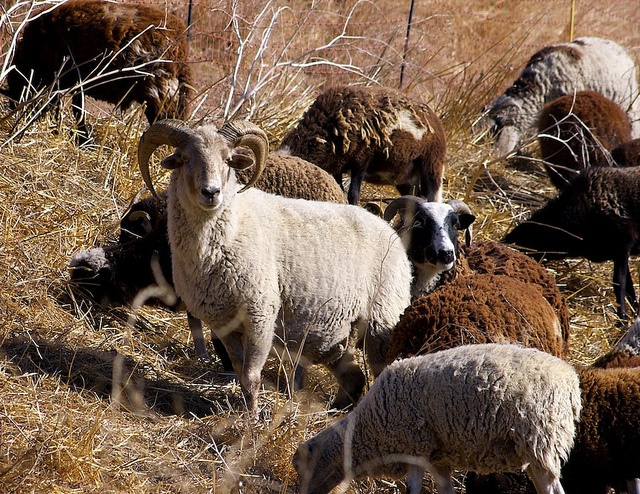Describe the objects in this image and their specific colors. I can see sheep in darkgreen, lightgray, black, and darkgray tones, sheep in darkgreen, black, gray, and lightgray tones, sheep in darkgreen, black, maroon, and gray tones, sheep in darkgreen, black, maroon, and gray tones, and sheep in darkgreen, black, maroon, brown, and gray tones in this image. 